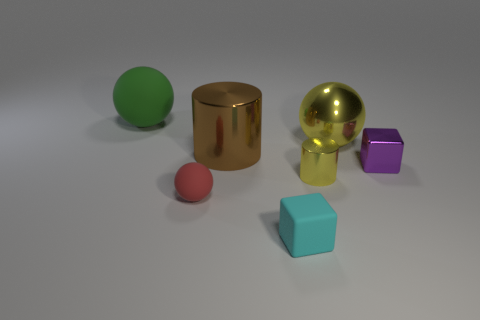The small block that is right of the matte thing right of the brown metal cylinder is made of what material?
Offer a very short reply. Metal. What is the material of the thing that is the same color as the metal sphere?
Provide a succinct answer. Metal. The small ball has what color?
Offer a terse response. Red. There is a tiny block that is on the right side of the tiny cylinder; are there any small rubber spheres that are behind it?
Your response must be concise. No. What is the yellow sphere made of?
Provide a short and direct response. Metal. Does the cube in front of the tiny yellow cylinder have the same material as the ball to the left of the red object?
Your answer should be compact. Yes. Is there any other thing that is the same color as the small ball?
Your answer should be very brief. No. What is the color of the other rubber thing that is the same shape as the tiny purple object?
Provide a short and direct response. Cyan. What is the size of the matte object that is both behind the cyan thing and right of the large green thing?
Give a very brief answer. Small. Do the yellow metal thing that is behind the yellow cylinder and the yellow metallic thing that is in front of the brown metallic object have the same shape?
Make the answer very short. No. 